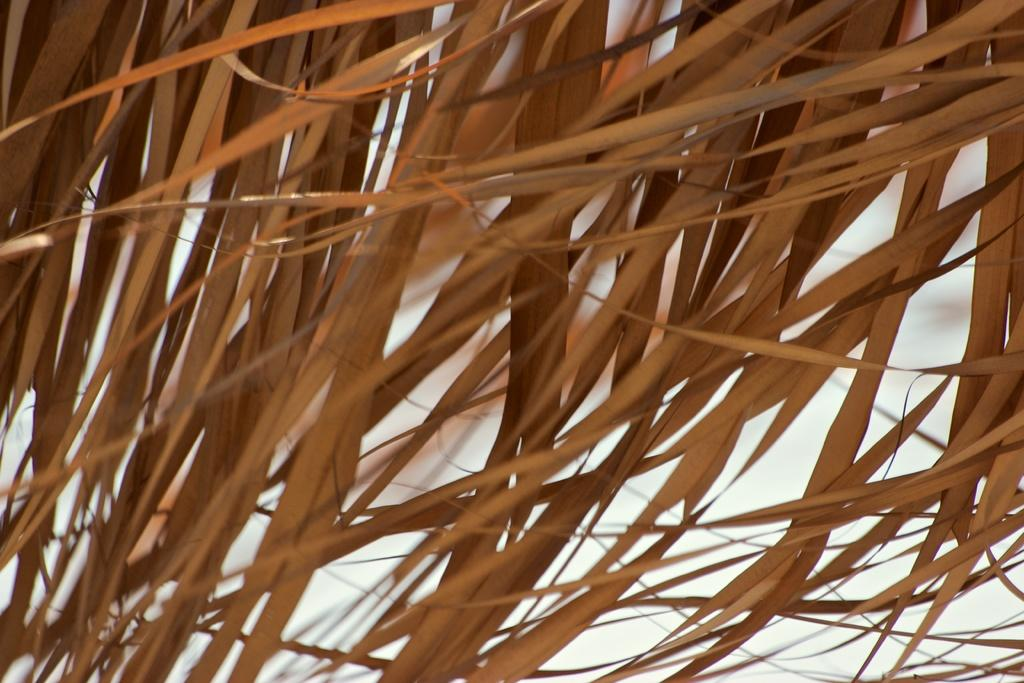What type of vegetation is present in the image? There is dry grass in the image. What color is the dry grass? The dry grass is in brown color. What color is the background of the image? The background of the image is in white color. What type of bell can be seen hanging from the dry grass in the image? There is no bell present in the image; it only features dry grass and a white background. 